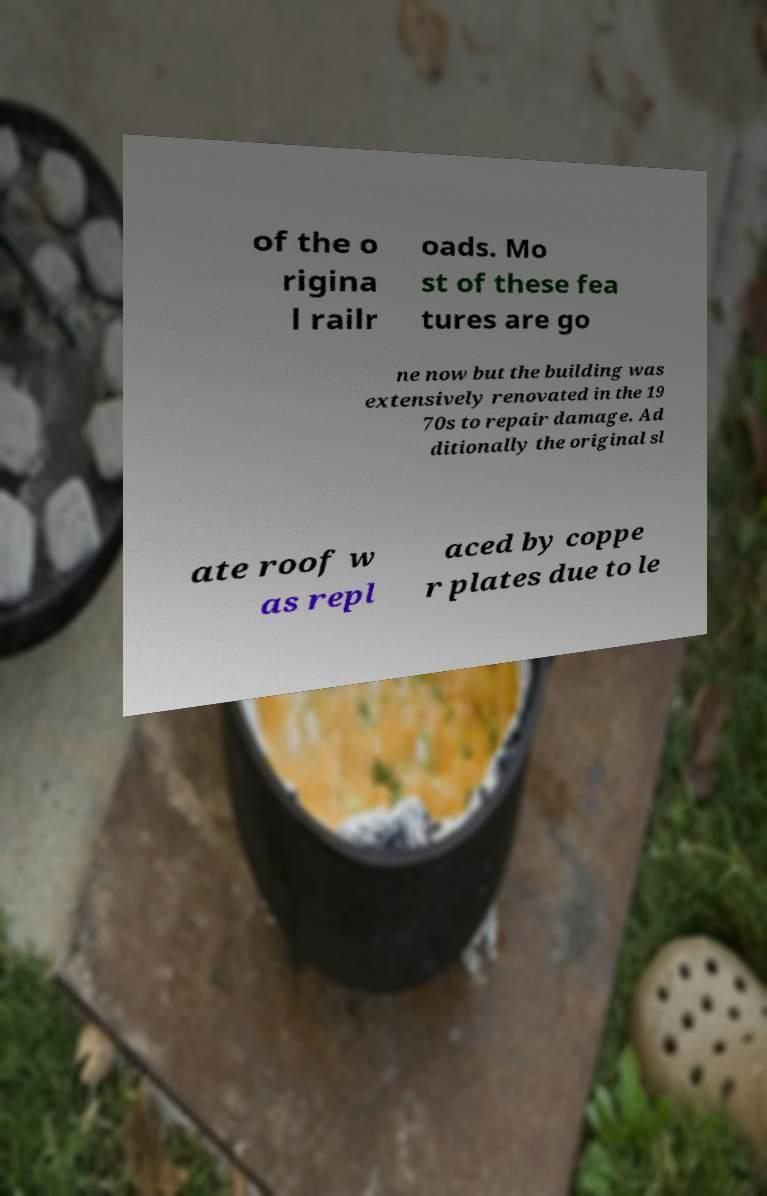Please identify and transcribe the text found in this image. of the o rigina l railr oads. Mo st of these fea tures are go ne now but the building was extensively renovated in the 19 70s to repair damage. Ad ditionally the original sl ate roof w as repl aced by coppe r plates due to le 